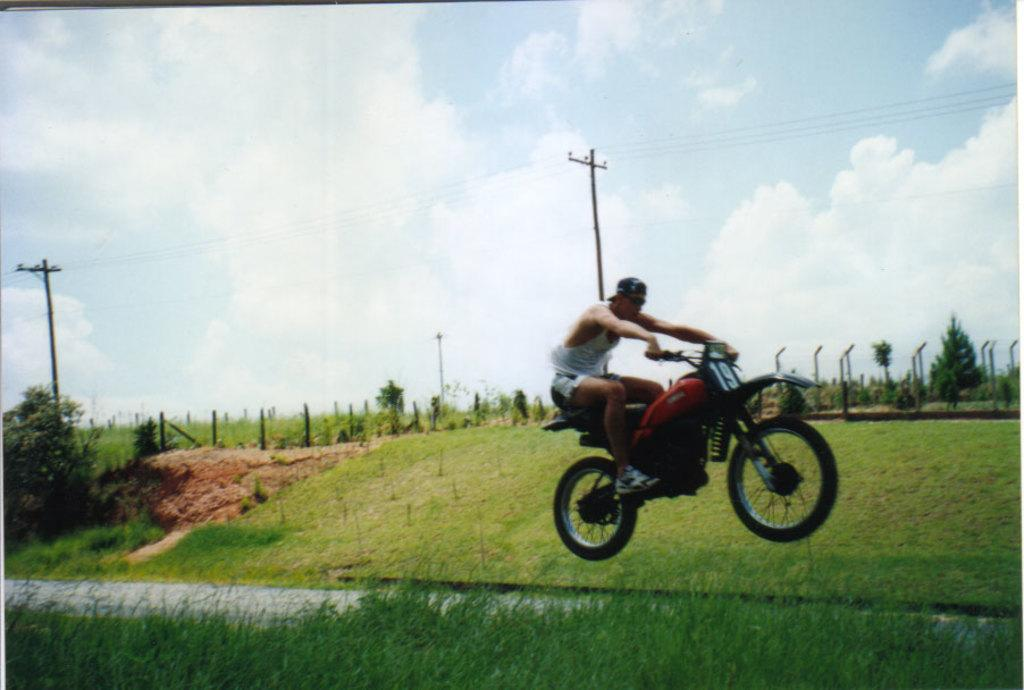What is the main subject of the image? There is a person in the image. What is the person doing in the image? The person is on a motorbike. What is unique about the motorbike's position in the image? The motorbike is in the air. What type of vegetation can be seen at the bottom of the image? There are plants at the bottom of the image. What can be seen in the background of the image? There are trees, grass, poles, and the sky visible in the background of the image. What type of baseball interest does the person on the motorbike have? There is no mention of baseball or any interest in the image, so it cannot be determined from the image. 